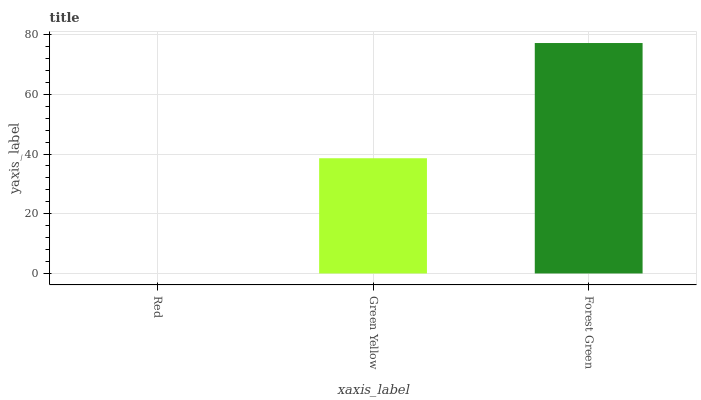Is Red the minimum?
Answer yes or no. Yes. Is Forest Green the maximum?
Answer yes or no. Yes. Is Green Yellow the minimum?
Answer yes or no. No. Is Green Yellow the maximum?
Answer yes or no. No. Is Green Yellow greater than Red?
Answer yes or no. Yes. Is Red less than Green Yellow?
Answer yes or no. Yes. Is Red greater than Green Yellow?
Answer yes or no. No. Is Green Yellow less than Red?
Answer yes or no. No. Is Green Yellow the high median?
Answer yes or no. Yes. Is Green Yellow the low median?
Answer yes or no. Yes. Is Forest Green the high median?
Answer yes or no. No. Is Forest Green the low median?
Answer yes or no. No. 